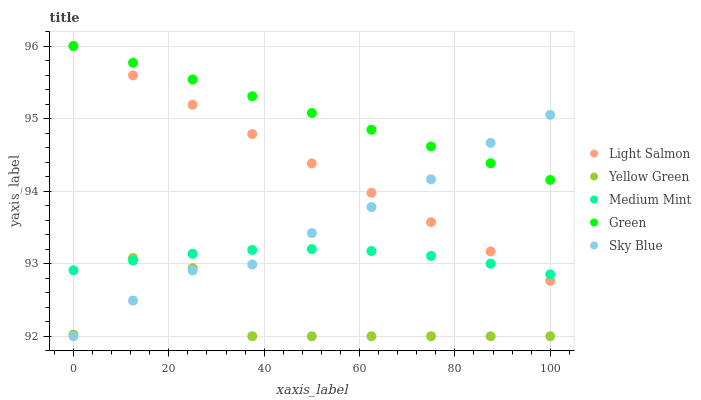Does Yellow Green have the minimum area under the curve?
Answer yes or no. Yes. Does Green have the maximum area under the curve?
Answer yes or no. Yes. Does Sky Blue have the minimum area under the curve?
Answer yes or no. No. Does Sky Blue have the maximum area under the curve?
Answer yes or no. No. Is Green the smoothest?
Answer yes or no. Yes. Is Yellow Green the roughest?
Answer yes or no. Yes. Is Sky Blue the smoothest?
Answer yes or no. No. Is Sky Blue the roughest?
Answer yes or no. No. Does Sky Blue have the lowest value?
Answer yes or no. Yes. Does Light Salmon have the lowest value?
Answer yes or no. No. Does Green have the highest value?
Answer yes or no. Yes. Does Sky Blue have the highest value?
Answer yes or no. No. Is Yellow Green less than Light Salmon?
Answer yes or no. Yes. Is Light Salmon greater than Yellow Green?
Answer yes or no. Yes. Does Yellow Green intersect Medium Mint?
Answer yes or no. Yes. Is Yellow Green less than Medium Mint?
Answer yes or no. No. Is Yellow Green greater than Medium Mint?
Answer yes or no. No. Does Yellow Green intersect Light Salmon?
Answer yes or no. No. 